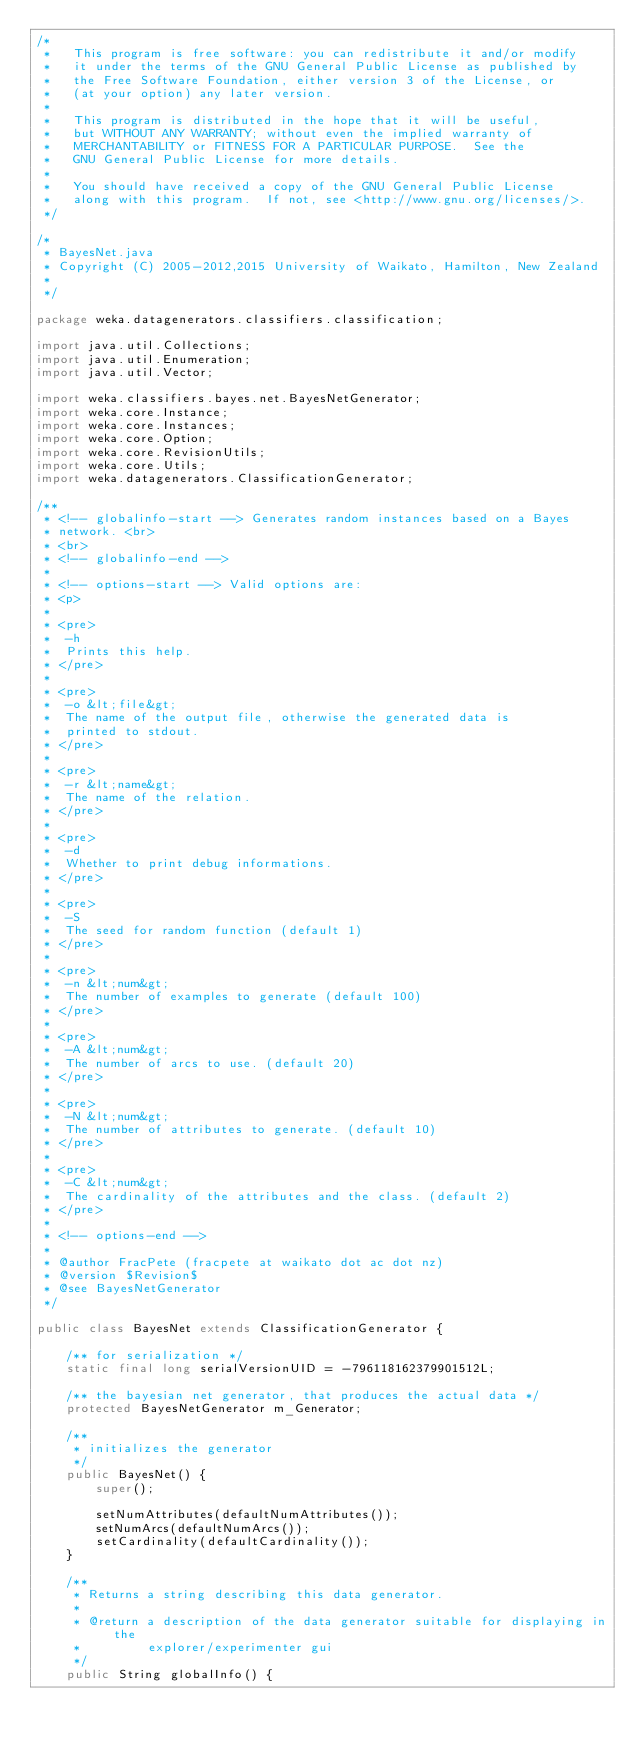<code> <loc_0><loc_0><loc_500><loc_500><_Java_>/*
 *   This program is free software: you can redistribute it and/or modify
 *   it under the terms of the GNU General Public License as published by
 *   the Free Software Foundation, either version 3 of the License, or
 *   (at your option) any later version.
 *
 *   This program is distributed in the hope that it will be useful,
 *   but WITHOUT ANY WARRANTY; without even the implied warranty of
 *   MERCHANTABILITY or FITNESS FOR A PARTICULAR PURPOSE.  See the
 *   GNU General Public License for more details.
 *
 *   You should have received a copy of the GNU General Public License
 *   along with this program.  If not, see <http://www.gnu.org/licenses/>.
 */

/*
 * BayesNet.java
 * Copyright (C) 2005-2012,2015 University of Waikato, Hamilton, New Zealand
 *
 */

package weka.datagenerators.classifiers.classification;

import java.util.Collections;
import java.util.Enumeration;
import java.util.Vector;

import weka.classifiers.bayes.net.BayesNetGenerator;
import weka.core.Instance;
import weka.core.Instances;
import weka.core.Option;
import weka.core.RevisionUtils;
import weka.core.Utils;
import weka.datagenerators.ClassificationGenerator;

/**
 * <!-- globalinfo-start --> Generates random instances based on a Bayes
 * network. <br>
 * <br>
 * <!-- globalinfo-end -->
 * 
 * <!-- options-start --> Valid options are:
 * <p>
 * 
 * <pre>
 *  -h
 *  Prints this help.
 * </pre>
 * 
 * <pre>
 *  -o &lt;file&gt;
 *  The name of the output file, otherwise the generated data is
 *  printed to stdout.
 * </pre>
 * 
 * <pre>
 *  -r &lt;name&gt;
 *  The name of the relation.
 * </pre>
 * 
 * <pre>
 *  -d
 *  Whether to print debug informations.
 * </pre>
 * 
 * <pre>
 *  -S
 *  The seed for random function (default 1)
 * </pre>
 * 
 * <pre>
 *  -n &lt;num&gt;
 *  The number of examples to generate (default 100)
 * </pre>
 * 
 * <pre>
 *  -A &lt;num&gt;
 *  The number of arcs to use. (default 20)
 * </pre>
 * 
 * <pre>
 *  -N &lt;num&gt;
 *  The number of attributes to generate. (default 10)
 * </pre>
 * 
 * <pre>
 *  -C &lt;num&gt;
 *  The cardinality of the attributes and the class. (default 2)
 * </pre>
 * 
 * <!-- options-end -->
 * 
 * @author FracPete (fracpete at waikato dot ac dot nz)
 * @version $Revision$
 * @see BayesNetGenerator
 */

public class BayesNet extends ClassificationGenerator {

    /** for serialization */
    static final long serialVersionUID = -796118162379901512L;

    /** the bayesian net generator, that produces the actual data */
    protected BayesNetGenerator m_Generator;

    /**
     * initializes the generator
     */
    public BayesNet() {
        super();

        setNumAttributes(defaultNumAttributes());
        setNumArcs(defaultNumArcs());
        setCardinality(defaultCardinality());
    }

    /**
     * Returns a string describing this data generator.
     * 
     * @return a description of the data generator suitable for displaying in the
     *         explorer/experimenter gui
     */
    public String globalInfo() {</code> 